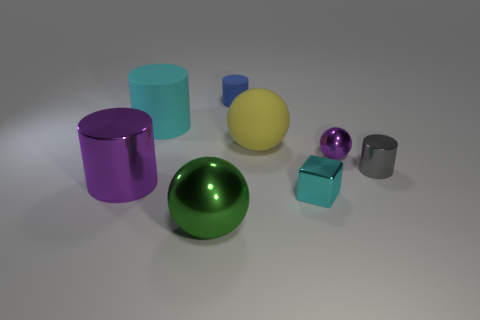What number of large things are both to the right of the tiny blue rubber cylinder and in front of the purple sphere?
Give a very brief answer. 0. What size is the purple shiny object that is left of the small thing that is left of the big yellow matte object?
Offer a very short reply. Large. Is the number of big matte things greater than the number of blue objects?
Your answer should be very brief. Yes. Is the color of the large sphere to the right of the green metallic sphere the same as the tiny cylinder that is in front of the yellow matte ball?
Ensure brevity in your answer.  No. Is there a small purple metallic sphere on the left side of the large sphere that is in front of the large purple metallic object?
Your answer should be very brief. No. Are there fewer small metallic things behind the big cyan thing than tiny metal cylinders behind the tiny blue cylinder?
Make the answer very short. No. Is the big sphere that is behind the big green metal sphere made of the same material as the purple thing that is on the right side of the block?
Your response must be concise. No. What number of small things are either yellow spheres or gray rubber spheres?
Make the answer very short. 0. The tiny cyan thing that is made of the same material as the gray object is what shape?
Keep it short and to the point. Cube. Is the number of large rubber cylinders that are right of the big yellow matte ball less than the number of red cylinders?
Offer a terse response. No. 